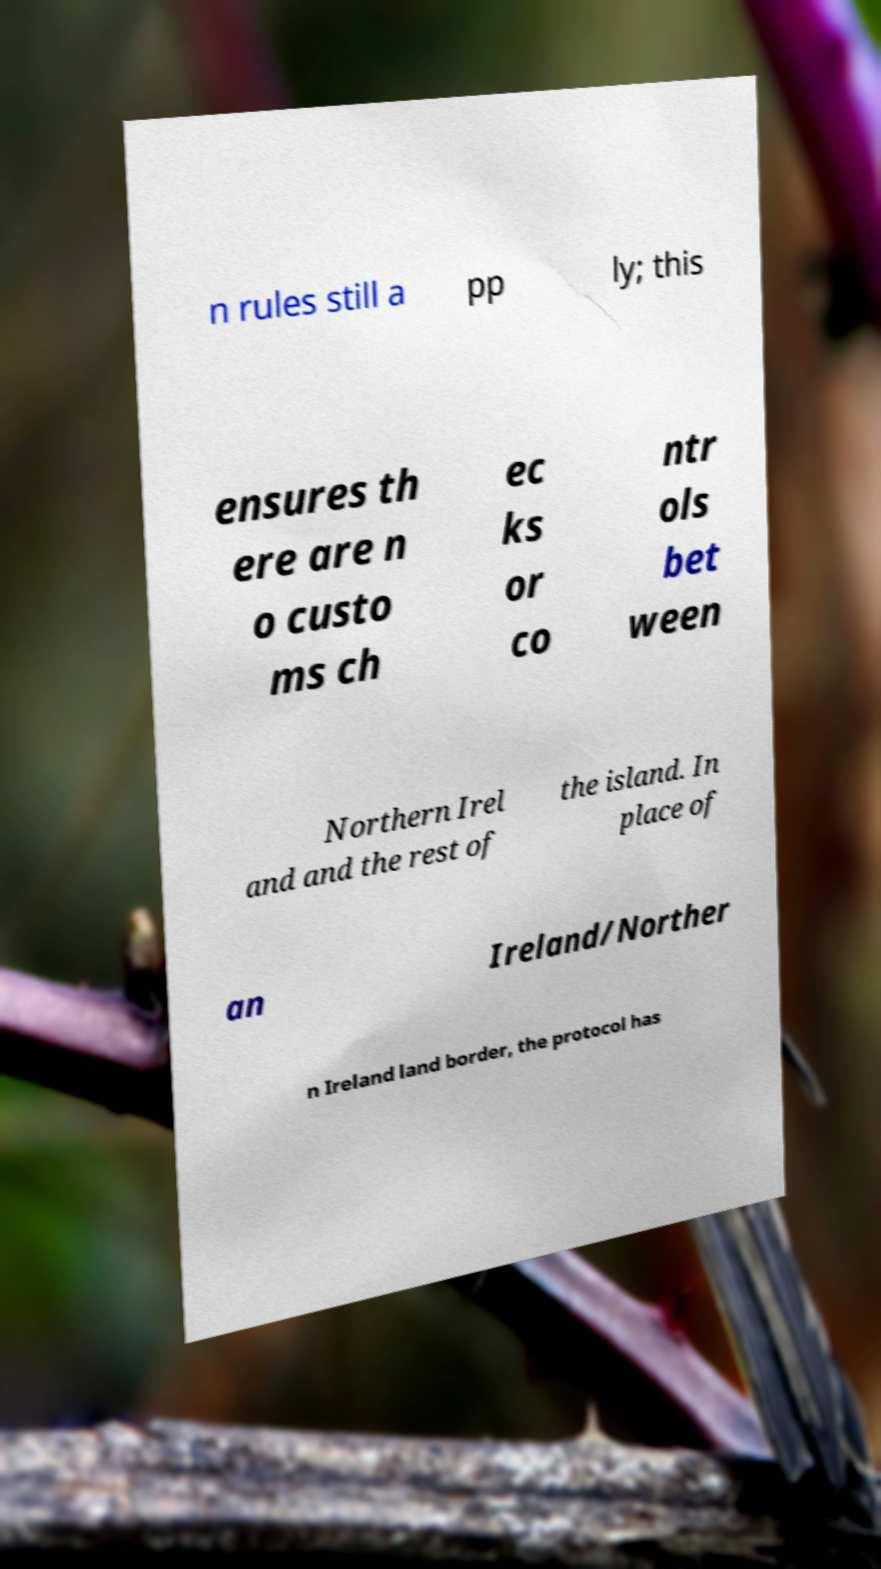Please identify and transcribe the text found in this image. n rules still a pp ly; this ensures th ere are n o custo ms ch ec ks or co ntr ols bet ween Northern Irel and and the rest of the island. In place of an Ireland/Norther n Ireland land border, the protocol has 